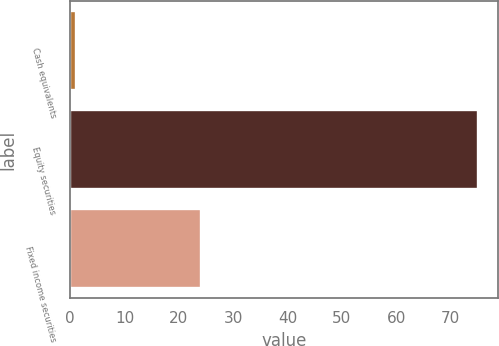<chart> <loc_0><loc_0><loc_500><loc_500><bar_chart><fcel>Cash equivalents<fcel>Equity securities<fcel>Fixed income securities<nl><fcel>1<fcel>75<fcel>24<nl></chart> 